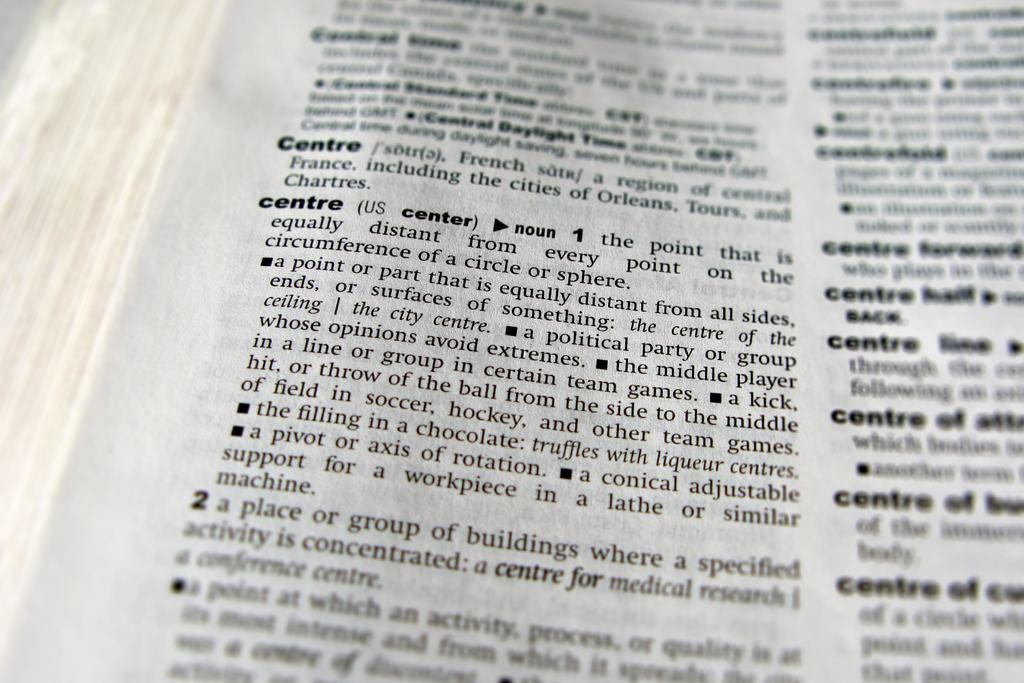What is depicted in the image? There is a picture of a paper in the image. Where is the paper located? The paper is in a book. What can be found on the paper? There is text on the paper. How many rabbits are visible on the paper in the image? There are no rabbits visible on the paper in the image; it only contains text. 